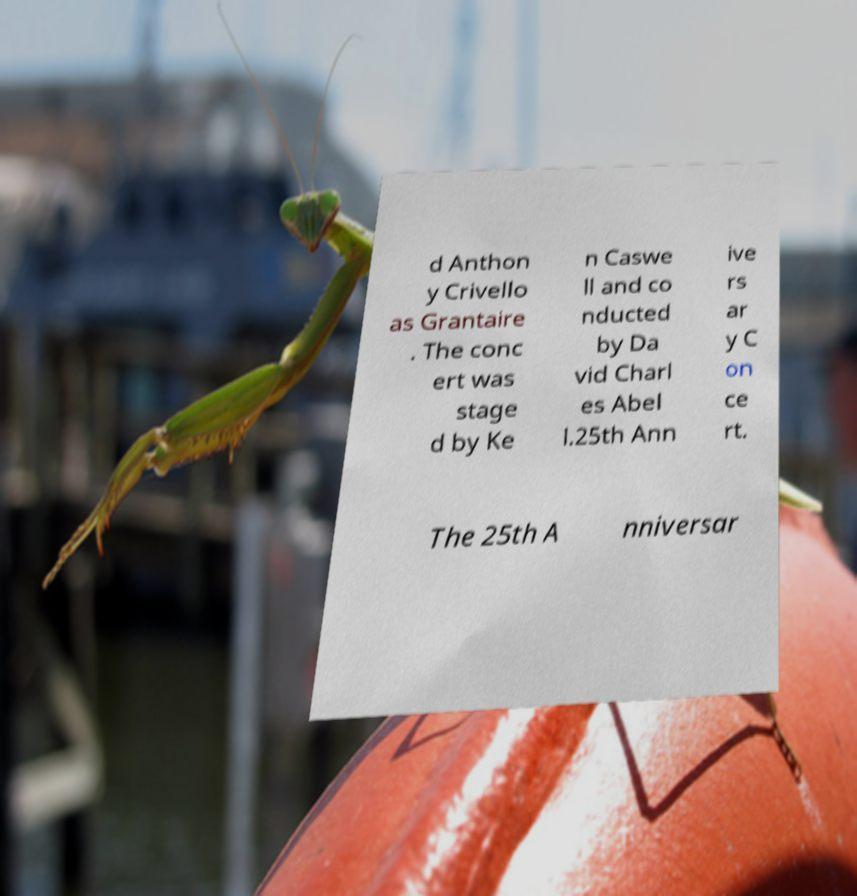What messages or text are displayed in this image? I need them in a readable, typed format. d Anthon y Crivello as Grantaire . The conc ert was stage d by Ke n Caswe ll and co nducted by Da vid Charl es Abel l.25th Ann ive rs ar y C on ce rt. The 25th A nniversar 